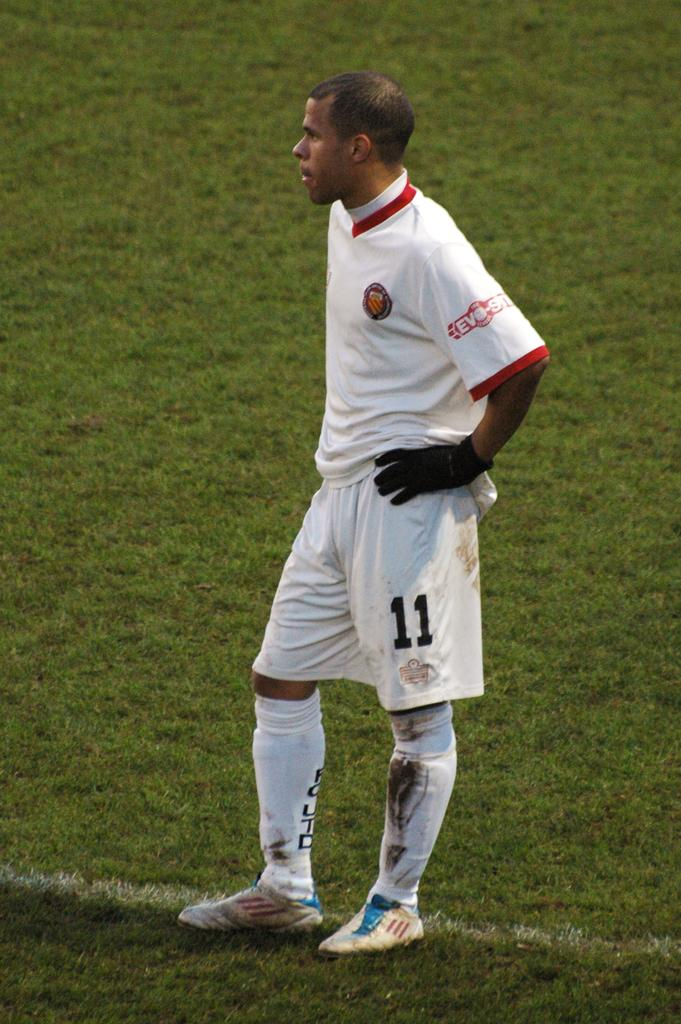<image>
Summarize the visual content of the image. Soccer player number 11 is all in white except for the black gloves. 